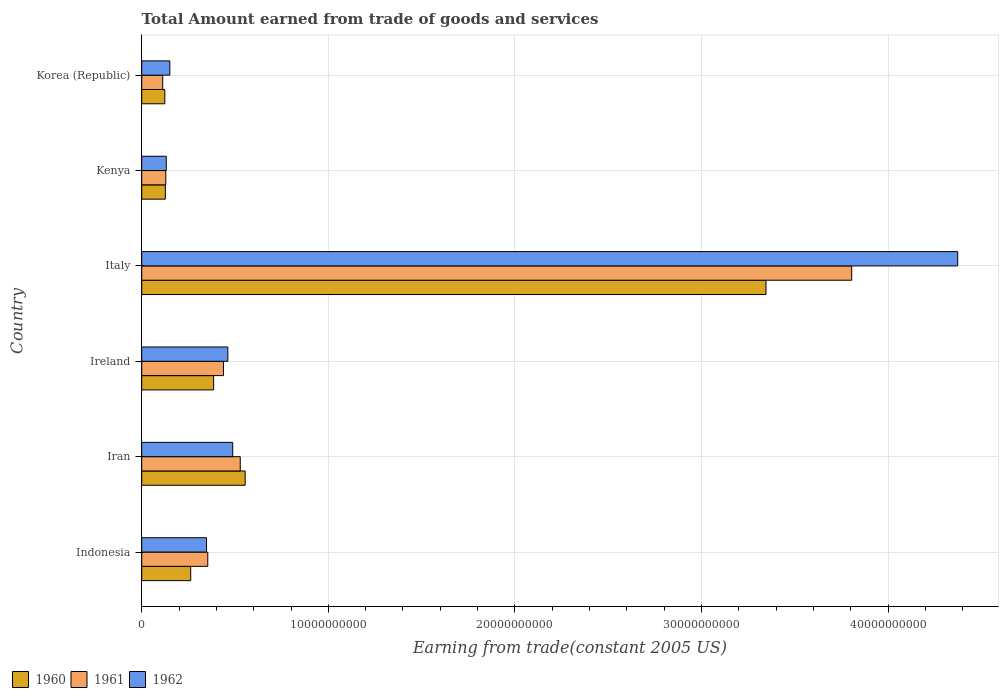How many different coloured bars are there?
Keep it short and to the point. 3. How many groups of bars are there?
Provide a succinct answer. 6. Are the number of bars per tick equal to the number of legend labels?
Give a very brief answer. Yes. Are the number of bars on each tick of the Y-axis equal?
Ensure brevity in your answer.  Yes. How many bars are there on the 2nd tick from the bottom?
Your response must be concise. 3. What is the label of the 5th group of bars from the top?
Your answer should be compact. Iran. What is the total amount earned by trading goods and services in 1960 in Iran?
Offer a very short reply. 5.54e+09. Across all countries, what is the maximum total amount earned by trading goods and services in 1961?
Provide a succinct answer. 3.81e+1. Across all countries, what is the minimum total amount earned by trading goods and services in 1961?
Ensure brevity in your answer.  1.12e+09. In which country was the total amount earned by trading goods and services in 1962 minimum?
Keep it short and to the point. Kenya. What is the total total amount earned by trading goods and services in 1962 in the graph?
Your answer should be very brief. 5.95e+1. What is the difference between the total amount earned by trading goods and services in 1961 in Ireland and that in Italy?
Give a very brief answer. -3.37e+1. What is the difference between the total amount earned by trading goods and services in 1961 in Iran and the total amount earned by trading goods and services in 1960 in Indonesia?
Provide a succinct answer. 2.65e+09. What is the average total amount earned by trading goods and services in 1961 per country?
Keep it short and to the point. 8.94e+09. What is the difference between the total amount earned by trading goods and services in 1961 and total amount earned by trading goods and services in 1962 in Italy?
Make the answer very short. -5.68e+09. In how many countries, is the total amount earned by trading goods and services in 1960 greater than 12000000000 US$?
Ensure brevity in your answer.  1. What is the ratio of the total amount earned by trading goods and services in 1961 in Indonesia to that in Korea (Republic)?
Your answer should be compact. 3.15. What is the difference between the highest and the second highest total amount earned by trading goods and services in 1960?
Provide a succinct answer. 2.79e+1. What is the difference between the highest and the lowest total amount earned by trading goods and services in 1960?
Your answer should be very brief. 3.22e+1. In how many countries, is the total amount earned by trading goods and services in 1961 greater than the average total amount earned by trading goods and services in 1961 taken over all countries?
Your response must be concise. 1. Is the sum of the total amount earned by trading goods and services in 1962 in Iran and Italy greater than the maximum total amount earned by trading goods and services in 1961 across all countries?
Your response must be concise. Yes. What does the 2nd bar from the bottom in Italy represents?
Your response must be concise. 1961. Is it the case that in every country, the sum of the total amount earned by trading goods and services in 1961 and total amount earned by trading goods and services in 1962 is greater than the total amount earned by trading goods and services in 1960?
Provide a succinct answer. Yes. How many countries are there in the graph?
Make the answer very short. 6. What is the difference between two consecutive major ticks on the X-axis?
Give a very brief answer. 1.00e+1. Does the graph contain any zero values?
Your response must be concise. No. Does the graph contain grids?
Offer a terse response. Yes. What is the title of the graph?
Ensure brevity in your answer.  Total Amount earned from trade of goods and services. Does "1976" appear as one of the legend labels in the graph?
Offer a terse response. No. What is the label or title of the X-axis?
Your response must be concise. Earning from trade(constant 2005 US). What is the label or title of the Y-axis?
Offer a very short reply. Country. What is the Earning from trade(constant 2005 US) of 1960 in Indonesia?
Your answer should be compact. 2.63e+09. What is the Earning from trade(constant 2005 US) in 1961 in Indonesia?
Give a very brief answer. 3.54e+09. What is the Earning from trade(constant 2005 US) in 1962 in Indonesia?
Make the answer very short. 3.47e+09. What is the Earning from trade(constant 2005 US) in 1960 in Iran?
Ensure brevity in your answer.  5.54e+09. What is the Earning from trade(constant 2005 US) in 1961 in Iran?
Give a very brief answer. 5.28e+09. What is the Earning from trade(constant 2005 US) of 1962 in Iran?
Offer a very short reply. 4.88e+09. What is the Earning from trade(constant 2005 US) of 1960 in Ireland?
Offer a terse response. 3.85e+09. What is the Earning from trade(constant 2005 US) of 1961 in Ireland?
Provide a succinct answer. 4.38e+09. What is the Earning from trade(constant 2005 US) of 1962 in Ireland?
Provide a short and direct response. 4.62e+09. What is the Earning from trade(constant 2005 US) of 1960 in Italy?
Your answer should be compact. 3.35e+1. What is the Earning from trade(constant 2005 US) of 1961 in Italy?
Ensure brevity in your answer.  3.81e+1. What is the Earning from trade(constant 2005 US) of 1962 in Italy?
Provide a succinct answer. 4.37e+1. What is the Earning from trade(constant 2005 US) in 1960 in Kenya?
Give a very brief answer. 1.27e+09. What is the Earning from trade(constant 2005 US) of 1961 in Kenya?
Offer a very short reply. 1.29e+09. What is the Earning from trade(constant 2005 US) of 1962 in Kenya?
Your answer should be compact. 1.32e+09. What is the Earning from trade(constant 2005 US) of 1960 in Korea (Republic)?
Provide a short and direct response. 1.24e+09. What is the Earning from trade(constant 2005 US) of 1961 in Korea (Republic)?
Your response must be concise. 1.12e+09. What is the Earning from trade(constant 2005 US) of 1962 in Korea (Republic)?
Offer a terse response. 1.51e+09. Across all countries, what is the maximum Earning from trade(constant 2005 US) of 1960?
Offer a terse response. 3.35e+1. Across all countries, what is the maximum Earning from trade(constant 2005 US) in 1961?
Your response must be concise. 3.81e+1. Across all countries, what is the maximum Earning from trade(constant 2005 US) of 1962?
Make the answer very short. 4.37e+1. Across all countries, what is the minimum Earning from trade(constant 2005 US) in 1960?
Your response must be concise. 1.24e+09. Across all countries, what is the minimum Earning from trade(constant 2005 US) of 1961?
Your response must be concise. 1.12e+09. Across all countries, what is the minimum Earning from trade(constant 2005 US) in 1962?
Ensure brevity in your answer.  1.32e+09. What is the total Earning from trade(constant 2005 US) of 1960 in the graph?
Give a very brief answer. 4.80e+1. What is the total Earning from trade(constant 2005 US) of 1961 in the graph?
Make the answer very short. 5.37e+1. What is the total Earning from trade(constant 2005 US) in 1962 in the graph?
Give a very brief answer. 5.95e+1. What is the difference between the Earning from trade(constant 2005 US) in 1960 in Indonesia and that in Iran?
Offer a terse response. -2.92e+09. What is the difference between the Earning from trade(constant 2005 US) in 1961 in Indonesia and that in Iran?
Your response must be concise. -1.74e+09. What is the difference between the Earning from trade(constant 2005 US) in 1962 in Indonesia and that in Iran?
Ensure brevity in your answer.  -1.40e+09. What is the difference between the Earning from trade(constant 2005 US) of 1960 in Indonesia and that in Ireland?
Offer a very short reply. -1.23e+09. What is the difference between the Earning from trade(constant 2005 US) in 1961 in Indonesia and that in Ireland?
Your response must be concise. -8.41e+08. What is the difference between the Earning from trade(constant 2005 US) of 1962 in Indonesia and that in Ireland?
Provide a succinct answer. -1.14e+09. What is the difference between the Earning from trade(constant 2005 US) of 1960 in Indonesia and that in Italy?
Your answer should be compact. -3.08e+1. What is the difference between the Earning from trade(constant 2005 US) of 1961 in Indonesia and that in Italy?
Provide a succinct answer. -3.45e+1. What is the difference between the Earning from trade(constant 2005 US) in 1962 in Indonesia and that in Italy?
Make the answer very short. -4.03e+1. What is the difference between the Earning from trade(constant 2005 US) in 1960 in Indonesia and that in Kenya?
Provide a short and direct response. 1.36e+09. What is the difference between the Earning from trade(constant 2005 US) in 1961 in Indonesia and that in Kenya?
Your answer should be compact. 2.25e+09. What is the difference between the Earning from trade(constant 2005 US) of 1962 in Indonesia and that in Kenya?
Offer a terse response. 2.16e+09. What is the difference between the Earning from trade(constant 2005 US) of 1960 in Indonesia and that in Korea (Republic)?
Ensure brevity in your answer.  1.39e+09. What is the difference between the Earning from trade(constant 2005 US) of 1961 in Indonesia and that in Korea (Republic)?
Ensure brevity in your answer.  2.42e+09. What is the difference between the Earning from trade(constant 2005 US) of 1962 in Indonesia and that in Korea (Republic)?
Your answer should be very brief. 1.97e+09. What is the difference between the Earning from trade(constant 2005 US) in 1960 in Iran and that in Ireland?
Give a very brief answer. 1.69e+09. What is the difference between the Earning from trade(constant 2005 US) of 1961 in Iran and that in Ireland?
Offer a very short reply. 9.00e+08. What is the difference between the Earning from trade(constant 2005 US) in 1962 in Iran and that in Ireland?
Give a very brief answer. 2.61e+08. What is the difference between the Earning from trade(constant 2005 US) in 1960 in Iran and that in Italy?
Ensure brevity in your answer.  -2.79e+1. What is the difference between the Earning from trade(constant 2005 US) of 1961 in Iran and that in Italy?
Give a very brief answer. -3.28e+1. What is the difference between the Earning from trade(constant 2005 US) in 1962 in Iran and that in Italy?
Offer a terse response. -3.89e+1. What is the difference between the Earning from trade(constant 2005 US) in 1960 in Iran and that in Kenya?
Your answer should be compact. 4.28e+09. What is the difference between the Earning from trade(constant 2005 US) of 1961 in Iran and that in Kenya?
Keep it short and to the point. 3.99e+09. What is the difference between the Earning from trade(constant 2005 US) in 1962 in Iran and that in Kenya?
Give a very brief answer. 3.56e+09. What is the difference between the Earning from trade(constant 2005 US) of 1960 in Iran and that in Korea (Republic)?
Ensure brevity in your answer.  4.31e+09. What is the difference between the Earning from trade(constant 2005 US) in 1961 in Iran and that in Korea (Republic)?
Make the answer very short. 4.16e+09. What is the difference between the Earning from trade(constant 2005 US) of 1962 in Iran and that in Korea (Republic)?
Give a very brief answer. 3.37e+09. What is the difference between the Earning from trade(constant 2005 US) of 1960 in Ireland and that in Italy?
Your answer should be compact. -2.96e+1. What is the difference between the Earning from trade(constant 2005 US) in 1961 in Ireland and that in Italy?
Provide a succinct answer. -3.37e+1. What is the difference between the Earning from trade(constant 2005 US) of 1962 in Ireland and that in Italy?
Provide a succinct answer. -3.91e+1. What is the difference between the Earning from trade(constant 2005 US) in 1960 in Ireland and that in Kenya?
Your answer should be compact. 2.59e+09. What is the difference between the Earning from trade(constant 2005 US) of 1961 in Ireland and that in Kenya?
Make the answer very short. 3.09e+09. What is the difference between the Earning from trade(constant 2005 US) in 1962 in Ireland and that in Kenya?
Provide a short and direct response. 3.30e+09. What is the difference between the Earning from trade(constant 2005 US) in 1960 in Ireland and that in Korea (Republic)?
Provide a short and direct response. 2.62e+09. What is the difference between the Earning from trade(constant 2005 US) of 1961 in Ireland and that in Korea (Republic)?
Ensure brevity in your answer.  3.26e+09. What is the difference between the Earning from trade(constant 2005 US) of 1962 in Ireland and that in Korea (Republic)?
Provide a succinct answer. 3.11e+09. What is the difference between the Earning from trade(constant 2005 US) in 1960 in Italy and that in Kenya?
Provide a succinct answer. 3.22e+1. What is the difference between the Earning from trade(constant 2005 US) in 1961 in Italy and that in Kenya?
Your response must be concise. 3.68e+1. What is the difference between the Earning from trade(constant 2005 US) of 1962 in Italy and that in Kenya?
Offer a very short reply. 4.24e+1. What is the difference between the Earning from trade(constant 2005 US) of 1960 in Italy and that in Korea (Republic)?
Your response must be concise. 3.22e+1. What is the difference between the Earning from trade(constant 2005 US) in 1961 in Italy and that in Korea (Republic)?
Provide a succinct answer. 3.69e+1. What is the difference between the Earning from trade(constant 2005 US) in 1962 in Italy and that in Korea (Republic)?
Give a very brief answer. 4.22e+1. What is the difference between the Earning from trade(constant 2005 US) of 1960 in Kenya and that in Korea (Republic)?
Ensure brevity in your answer.  2.90e+07. What is the difference between the Earning from trade(constant 2005 US) in 1961 in Kenya and that in Korea (Republic)?
Your answer should be very brief. 1.67e+08. What is the difference between the Earning from trade(constant 2005 US) of 1962 in Kenya and that in Korea (Republic)?
Provide a short and direct response. -1.90e+08. What is the difference between the Earning from trade(constant 2005 US) of 1960 in Indonesia and the Earning from trade(constant 2005 US) of 1961 in Iran?
Your answer should be very brief. -2.65e+09. What is the difference between the Earning from trade(constant 2005 US) in 1960 in Indonesia and the Earning from trade(constant 2005 US) in 1962 in Iran?
Ensure brevity in your answer.  -2.25e+09. What is the difference between the Earning from trade(constant 2005 US) in 1961 in Indonesia and the Earning from trade(constant 2005 US) in 1962 in Iran?
Give a very brief answer. -1.34e+09. What is the difference between the Earning from trade(constant 2005 US) in 1960 in Indonesia and the Earning from trade(constant 2005 US) in 1961 in Ireland?
Ensure brevity in your answer.  -1.75e+09. What is the difference between the Earning from trade(constant 2005 US) of 1960 in Indonesia and the Earning from trade(constant 2005 US) of 1962 in Ireland?
Offer a terse response. -1.99e+09. What is the difference between the Earning from trade(constant 2005 US) in 1961 in Indonesia and the Earning from trade(constant 2005 US) in 1962 in Ireland?
Offer a terse response. -1.08e+09. What is the difference between the Earning from trade(constant 2005 US) of 1960 in Indonesia and the Earning from trade(constant 2005 US) of 1961 in Italy?
Your answer should be compact. -3.54e+1. What is the difference between the Earning from trade(constant 2005 US) in 1960 in Indonesia and the Earning from trade(constant 2005 US) in 1962 in Italy?
Provide a succinct answer. -4.11e+1. What is the difference between the Earning from trade(constant 2005 US) in 1961 in Indonesia and the Earning from trade(constant 2005 US) in 1962 in Italy?
Offer a very short reply. -4.02e+1. What is the difference between the Earning from trade(constant 2005 US) of 1960 in Indonesia and the Earning from trade(constant 2005 US) of 1961 in Kenya?
Provide a short and direct response. 1.33e+09. What is the difference between the Earning from trade(constant 2005 US) of 1960 in Indonesia and the Earning from trade(constant 2005 US) of 1962 in Kenya?
Give a very brief answer. 1.31e+09. What is the difference between the Earning from trade(constant 2005 US) of 1961 in Indonesia and the Earning from trade(constant 2005 US) of 1962 in Kenya?
Provide a short and direct response. 2.22e+09. What is the difference between the Earning from trade(constant 2005 US) of 1960 in Indonesia and the Earning from trade(constant 2005 US) of 1961 in Korea (Republic)?
Provide a short and direct response. 1.50e+09. What is the difference between the Earning from trade(constant 2005 US) of 1960 in Indonesia and the Earning from trade(constant 2005 US) of 1962 in Korea (Republic)?
Provide a short and direct response. 1.12e+09. What is the difference between the Earning from trade(constant 2005 US) of 1961 in Indonesia and the Earning from trade(constant 2005 US) of 1962 in Korea (Republic)?
Make the answer very short. 2.03e+09. What is the difference between the Earning from trade(constant 2005 US) in 1960 in Iran and the Earning from trade(constant 2005 US) in 1961 in Ireland?
Ensure brevity in your answer.  1.16e+09. What is the difference between the Earning from trade(constant 2005 US) in 1960 in Iran and the Earning from trade(constant 2005 US) in 1962 in Ireland?
Provide a succinct answer. 9.28e+08. What is the difference between the Earning from trade(constant 2005 US) in 1961 in Iran and the Earning from trade(constant 2005 US) in 1962 in Ireland?
Provide a short and direct response. 6.65e+08. What is the difference between the Earning from trade(constant 2005 US) in 1960 in Iran and the Earning from trade(constant 2005 US) in 1961 in Italy?
Give a very brief answer. -3.25e+1. What is the difference between the Earning from trade(constant 2005 US) in 1960 in Iran and the Earning from trade(constant 2005 US) in 1962 in Italy?
Provide a succinct answer. -3.82e+1. What is the difference between the Earning from trade(constant 2005 US) in 1961 in Iran and the Earning from trade(constant 2005 US) in 1962 in Italy?
Ensure brevity in your answer.  -3.85e+1. What is the difference between the Earning from trade(constant 2005 US) in 1960 in Iran and the Earning from trade(constant 2005 US) in 1961 in Kenya?
Your response must be concise. 4.25e+09. What is the difference between the Earning from trade(constant 2005 US) in 1960 in Iran and the Earning from trade(constant 2005 US) in 1962 in Kenya?
Ensure brevity in your answer.  4.23e+09. What is the difference between the Earning from trade(constant 2005 US) of 1961 in Iran and the Earning from trade(constant 2005 US) of 1962 in Kenya?
Your answer should be very brief. 3.96e+09. What is the difference between the Earning from trade(constant 2005 US) in 1960 in Iran and the Earning from trade(constant 2005 US) in 1961 in Korea (Republic)?
Your answer should be compact. 4.42e+09. What is the difference between the Earning from trade(constant 2005 US) in 1960 in Iran and the Earning from trade(constant 2005 US) in 1962 in Korea (Republic)?
Your answer should be very brief. 4.04e+09. What is the difference between the Earning from trade(constant 2005 US) of 1961 in Iran and the Earning from trade(constant 2005 US) of 1962 in Korea (Republic)?
Offer a very short reply. 3.77e+09. What is the difference between the Earning from trade(constant 2005 US) in 1960 in Ireland and the Earning from trade(constant 2005 US) in 1961 in Italy?
Your answer should be compact. -3.42e+1. What is the difference between the Earning from trade(constant 2005 US) of 1960 in Ireland and the Earning from trade(constant 2005 US) of 1962 in Italy?
Provide a short and direct response. -3.99e+1. What is the difference between the Earning from trade(constant 2005 US) of 1961 in Ireland and the Earning from trade(constant 2005 US) of 1962 in Italy?
Provide a succinct answer. -3.93e+1. What is the difference between the Earning from trade(constant 2005 US) in 1960 in Ireland and the Earning from trade(constant 2005 US) in 1961 in Kenya?
Your response must be concise. 2.56e+09. What is the difference between the Earning from trade(constant 2005 US) of 1960 in Ireland and the Earning from trade(constant 2005 US) of 1962 in Kenya?
Give a very brief answer. 2.54e+09. What is the difference between the Earning from trade(constant 2005 US) of 1961 in Ireland and the Earning from trade(constant 2005 US) of 1962 in Kenya?
Provide a short and direct response. 3.07e+09. What is the difference between the Earning from trade(constant 2005 US) of 1960 in Ireland and the Earning from trade(constant 2005 US) of 1961 in Korea (Republic)?
Your answer should be compact. 2.73e+09. What is the difference between the Earning from trade(constant 2005 US) of 1960 in Ireland and the Earning from trade(constant 2005 US) of 1962 in Korea (Republic)?
Make the answer very short. 2.35e+09. What is the difference between the Earning from trade(constant 2005 US) of 1961 in Ireland and the Earning from trade(constant 2005 US) of 1962 in Korea (Republic)?
Keep it short and to the point. 2.87e+09. What is the difference between the Earning from trade(constant 2005 US) in 1960 in Italy and the Earning from trade(constant 2005 US) in 1961 in Kenya?
Keep it short and to the point. 3.22e+1. What is the difference between the Earning from trade(constant 2005 US) of 1960 in Italy and the Earning from trade(constant 2005 US) of 1962 in Kenya?
Keep it short and to the point. 3.21e+1. What is the difference between the Earning from trade(constant 2005 US) of 1961 in Italy and the Earning from trade(constant 2005 US) of 1962 in Kenya?
Your answer should be very brief. 3.67e+1. What is the difference between the Earning from trade(constant 2005 US) in 1960 in Italy and the Earning from trade(constant 2005 US) in 1961 in Korea (Republic)?
Provide a succinct answer. 3.23e+1. What is the difference between the Earning from trade(constant 2005 US) in 1960 in Italy and the Earning from trade(constant 2005 US) in 1962 in Korea (Republic)?
Provide a succinct answer. 3.19e+1. What is the difference between the Earning from trade(constant 2005 US) in 1961 in Italy and the Earning from trade(constant 2005 US) in 1962 in Korea (Republic)?
Offer a terse response. 3.65e+1. What is the difference between the Earning from trade(constant 2005 US) of 1960 in Kenya and the Earning from trade(constant 2005 US) of 1961 in Korea (Republic)?
Offer a very short reply. 1.42e+08. What is the difference between the Earning from trade(constant 2005 US) in 1960 in Kenya and the Earning from trade(constant 2005 US) in 1962 in Korea (Republic)?
Offer a very short reply. -2.40e+08. What is the difference between the Earning from trade(constant 2005 US) of 1961 in Kenya and the Earning from trade(constant 2005 US) of 1962 in Korea (Republic)?
Make the answer very short. -2.15e+08. What is the average Earning from trade(constant 2005 US) of 1960 per country?
Ensure brevity in your answer.  8.00e+09. What is the average Earning from trade(constant 2005 US) in 1961 per country?
Your response must be concise. 8.94e+09. What is the average Earning from trade(constant 2005 US) of 1962 per country?
Your answer should be very brief. 9.92e+09. What is the difference between the Earning from trade(constant 2005 US) in 1960 and Earning from trade(constant 2005 US) in 1961 in Indonesia?
Provide a succinct answer. -9.14e+08. What is the difference between the Earning from trade(constant 2005 US) of 1960 and Earning from trade(constant 2005 US) of 1962 in Indonesia?
Offer a very short reply. -8.46e+08. What is the difference between the Earning from trade(constant 2005 US) in 1961 and Earning from trade(constant 2005 US) in 1962 in Indonesia?
Give a very brief answer. 6.82e+07. What is the difference between the Earning from trade(constant 2005 US) in 1960 and Earning from trade(constant 2005 US) in 1961 in Iran?
Keep it short and to the point. 2.63e+08. What is the difference between the Earning from trade(constant 2005 US) in 1960 and Earning from trade(constant 2005 US) in 1962 in Iran?
Ensure brevity in your answer.  6.67e+08. What is the difference between the Earning from trade(constant 2005 US) in 1961 and Earning from trade(constant 2005 US) in 1962 in Iran?
Provide a short and direct response. 4.04e+08. What is the difference between the Earning from trade(constant 2005 US) of 1960 and Earning from trade(constant 2005 US) of 1961 in Ireland?
Offer a very short reply. -5.28e+08. What is the difference between the Earning from trade(constant 2005 US) in 1960 and Earning from trade(constant 2005 US) in 1962 in Ireland?
Your answer should be very brief. -7.62e+08. What is the difference between the Earning from trade(constant 2005 US) in 1961 and Earning from trade(constant 2005 US) in 1962 in Ireland?
Provide a succinct answer. -2.34e+08. What is the difference between the Earning from trade(constant 2005 US) of 1960 and Earning from trade(constant 2005 US) of 1961 in Italy?
Your answer should be compact. -4.59e+09. What is the difference between the Earning from trade(constant 2005 US) of 1960 and Earning from trade(constant 2005 US) of 1962 in Italy?
Make the answer very short. -1.03e+1. What is the difference between the Earning from trade(constant 2005 US) in 1961 and Earning from trade(constant 2005 US) in 1962 in Italy?
Offer a very short reply. -5.68e+09. What is the difference between the Earning from trade(constant 2005 US) of 1960 and Earning from trade(constant 2005 US) of 1961 in Kenya?
Give a very brief answer. -2.47e+07. What is the difference between the Earning from trade(constant 2005 US) in 1960 and Earning from trade(constant 2005 US) in 1962 in Kenya?
Offer a terse response. -4.93e+07. What is the difference between the Earning from trade(constant 2005 US) in 1961 and Earning from trade(constant 2005 US) in 1962 in Kenya?
Provide a short and direct response. -2.46e+07. What is the difference between the Earning from trade(constant 2005 US) in 1960 and Earning from trade(constant 2005 US) in 1961 in Korea (Republic)?
Ensure brevity in your answer.  1.13e+08. What is the difference between the Earning from trade(constant 2005 US) in 1960 and Earning from trade(constant 2005 US) in 1962 in Korea (Republic)?
Provide a short and direct response. -2.69e+08. What is the difference between the Earning from trade(constant 2005 US) of 1961 and Earning from trade(constant 2005 US) of 1962 in Korea (Republic)?
Give a very brief answer. -3.82e+08. What is the ratio of the Earning from trade(constant 2005 US) of 1960 in Indonesia to that in Iran?
Offer a very short reply. 0.47. What is the ratio of the Earning from trade(constant 2005 US) of 1961 in Indonesia to that in Iran?
Ensure brevity in your answer.  0.67. What is the ratio of the Earning from trade(constant 2005 US) of 1962 in Indonesia to that in Iran?
Your answer should be very brief. 0.71. What is the ratio of the Earning from trade(constant 2005 US) in 1960 in Indonesia to that in Ireland?
Offer a terse response. 0.68. What is the ratio of the Earning from trade(constant 2005 US) in 1961 in Indonesia to that in Ireland?
Keep it short and to the point. 0.81. What is the ratio of the Earning from trade(constant 2005 US) of 1962 in Indonesia to that in Ireland?
Keep it short and to the point. 0.75. What is the ratio of the Earning from trade(constant 2005 US) of 1960 in Indonesia to that in Italy?
Your response must be concise. 0.08. What is the ratio of the Earning from trade(constant 2005 US) in 1961 in Indonesia to that in Italy?
Keep it short and to the point. 0.09. What is the ratio of the Earning from trade(constant 2005 US) in 1962 in Indonesia to that in Italy?
Offer a terse response. 0.08. What is the ratio of the Earning from trade(constant 2005 US) in 1960 in Indonesia to that in Kenya?
Provide a succinct answer. 2.07. What is the ratio of the Earning from trade(constant 2005 US) in 1961 in Indonesia to that in Kenya?
Give a very brief answer. 2.74. What is the ratio of the Earning from trade(constant 2005 US) of 1962 in Indonesia to that in Kenya?
Provide a short and direct response. 2.64. What is the ratio of the Earning from trade(constant 2005 US) in 1960 in Indonesia to that in Korea (Republic)?
Your response must be concise. 2.12. What is the ratio of the Earning from trade(constant 2005 US) of 1961 in Indonesia to that in Korea (Republic)?
Offer a very short reply. 3.15. What is the ratio of the Earning from trade(constant 2005 US) of 1962 in Indonesia to that in Korea (Republic)?
Make the answer very short. 2.3. What is the ratio of the Earning from trade(constant 2005 US) in 1960 in Iran to that in Ireland?
Your response must be concise. 1.44. What is the ratio of the Earning from trade(constant 2005 US) in 1961 in Iran to that in Ireland?
Offer a terse response. 1.21. What is the ratio of the Earning from trade(constant 2005 US) of 1962 in Iran to that in Ireland?
Give a very brief answer. 1.06. What is the ratio of the Earning from trade(constant 2005 US) of 1960 in Iran to that in Italy?
Ensure brevity in your answer.  0.17. What is the ratio of the Earning from trade(constant 2005 US) in 1961 in Iran to that in Italy?
Your answer should be compact. 0.14. What is the ratio of the Earning from trade(constant 2005 US) of 1962 in Iran to that in Italy?
Make the answer very short. 0.11. What is the ratio of the Earning from trade(constant 2005 US) of 1960 in Iran to that in Kenya?
Offer a very short reply. 4.38. What is the ratio of the Earning from trade(constant 2005 US) in 1961 in Iran to that in Kenya?
Your answer should be compact. 4.09. What is the ratio of the Earning from trade(constant 2005 US) of 1962 in Iran to that in Kenya?
Your answer should be compact. 3.71. What is the ratio of the Earning from trade(constant 2005 US) in 1960 in Iran to that in Korea (Republic)?
Ensure brevity in your answer.  4.48. What is the ratio of the Earning from trade(constant 2005 US) of 1961 in Iran to that in Korea (Republic)?
Offer a terse response. 4.7. What is the ratio of the Earning from trade(constant 2005 US) of 1962 in Iran to that in Korea (Republic)?
Your answer should be compact. 3.24. What is the ratio of the Earning from trade(constant 2005 US) of 1960 in Ireland to that in Italy?
Provide a succinct answer. 0.12. What is the ratio of the Earning from trade(constant 2005 US) of 1961 in Ireland to that in Italy?
Ensure brevity in your answer.  0.12. What is the ratio of the Earning from trade(constant 2005 US) of 1962 in Ireland to that in Italy?
Ensure brevity in your answer.  0.11. What is the ratio of the Earning from trade(constant 2005 US) in 1960 in Ireland to that in Kenya?
Your response must be concise. 3.04. What is the ratio of the Earning from trade(constant 2005 US) in 1961 in Ireland to that in Kenya?
Provide a short and direct response. 3.39. What is the ratio of the Earning from trade(constant 2005 US) of 1962 in Ireland to that in Kenya?
Offer a terse response. 3.51. What is the ratio of the Earning from trade(constant 2005 US) of 1960 in Ireland to that in Korea (Republic)?
Offer a terse response. 3.11. What is the ratio of the Earning from trade(constant 2005 US) in 1961 in Ireland to that in Korea (Republic)?
Offer a terse response. 3.9. What is the ratio of the Earning from trade(constant 2005 US) in 1962 in Ireland to that in Korea (Republic)?
Ensure brevity in your answer.  3.06. What is the ratio of the Earning from trade(constant 2005 US) of 1960 in Italy to that in Kenya?
Your response must be concise. 26.41. What is the ratio of the Earning from trade(constant 2005 US) in 1961 in Italy to that in Kenya?
Provide a succinct answer. 29.47. What is the ratio of the Earning from trade(constant 2005 US) in 1962 in Italy to that in Kenya?
Provide a succinct answer. 33.23. What is the ratio of the Earning from trade(constant 2005 US) in 1960 in Italy to that in Korea (Republic)?
Your answer should be compact. 27.03. What is the ratio of the Earning from trade(constant 2005 US) of 1961 in Italy to that in Korea (Republic)?
Keep it short and to the point. 33.84. What is the ratio of the Earning from trade(constant 2005 US) of 1962 in Italy to that in Korea (Republic)?
Your answer should be compact. 29.03. What is the ratio of the Earning from trade(constant 2005 US) in 1960 in Kenya to that in Korea (Republic)?
Offer a terse response. 1.02. What is the ratio of the Earning from trade(constant 2005 US) in 1961 in Kenya to that in Korea (Republic)?
Your response must be concise. 1.15. What is the ratio of the Earning from trade(constant 2005 US) of 1962 in Kenya to that in Korea (Republic)?
Your answer should be compact. 0.87. What is the difference between the highest and the second highest Earning from trade(constant 2005 US) in 1960?
Provide a succinct answer. 2.79e+1. What is the difference between the highest and the second highest Earning from trade(constant 2005 US) of 1961?
Provide a succinct answer. 3.28e+1. What is the difference between the highest and the second highest Earning from trade(constant 2005 US) of 1962?
Your answer should be compact. 3.89e+1. What is the difference between the highest and the lowest Earning from trade(constant 2005 US) of 1960?
Make the answer very short. 3.22e+1. What is the difference between the highest and the lowest Earning from trade(constant 2005 US) of 1961?
Provide a succinct answer. 3.69e+1. What is the difference between the highest and the lowest Earning from trade(constant 2005 US) in 1962?
Provide a succinct answer. 4.24e+1. 